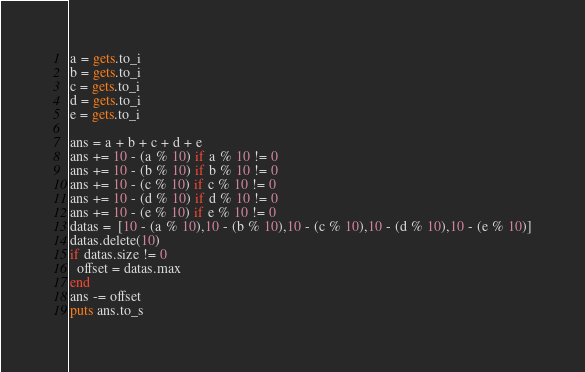Convert code to text. <code><loc_0><loc_0><loc_500><loc_500><_Ruby_>a = gets.to_i
b = gets.to_i
c = gets.to_i
d = gets.to_i
e = gets.to_i

ans = a + b + c + d + e
ans += 10 - (a % 10) if a % 10 != 0
ans += 10 - (b % 10) if b % 10 != 0
ans += 10 - (c % 10) if c % 10 != 0
ans += 10 - (d % 10) if d % 10 != 0
ans += 10 - (e % 10) if e % 10 != 0
datas =  [10 - (a % 10),10 - (b % 10),10 - (c % 10),10 - (d % 10),10 - (e % 10)]
datas.delete(10)
if datas.size != 0
  offset = datas.max
end
ans -= offset
puts ans.to_s</code> 